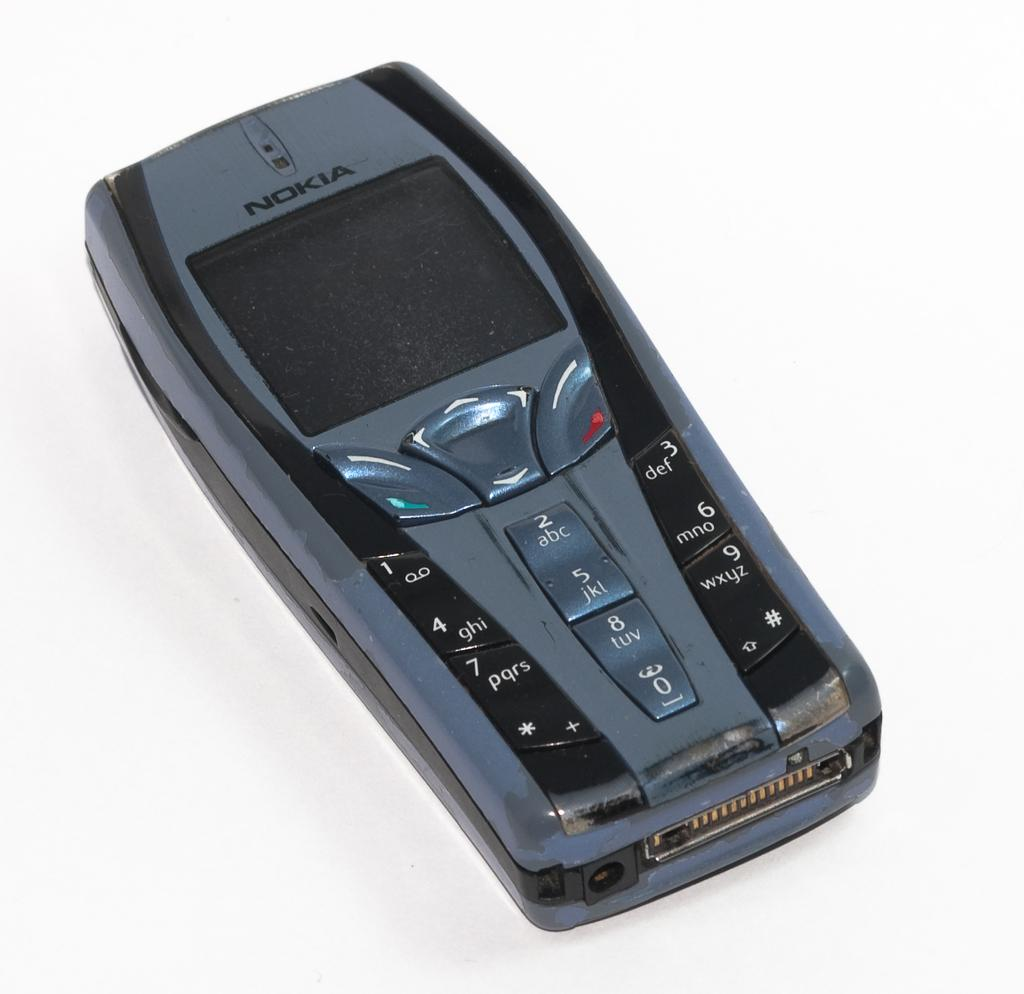What type of mobile phone is in the picture? There is a Nokia mobile phone in the picture. What can be seen on the mobile phone's keypad? The mobile phone has numbers on it. Are there any other buttons on the mobile phone besides the numbers? Yes, the mobile phone has other buttons on it. What type of error message is displayed on the church in the image? There is no church present in the image, and therefore no error message can be observed. 